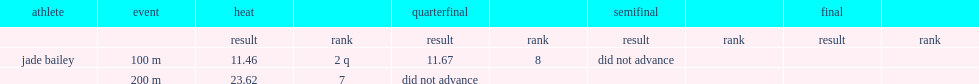What was the result that jade bailey got in the heat in the 200m event? 23.62. 